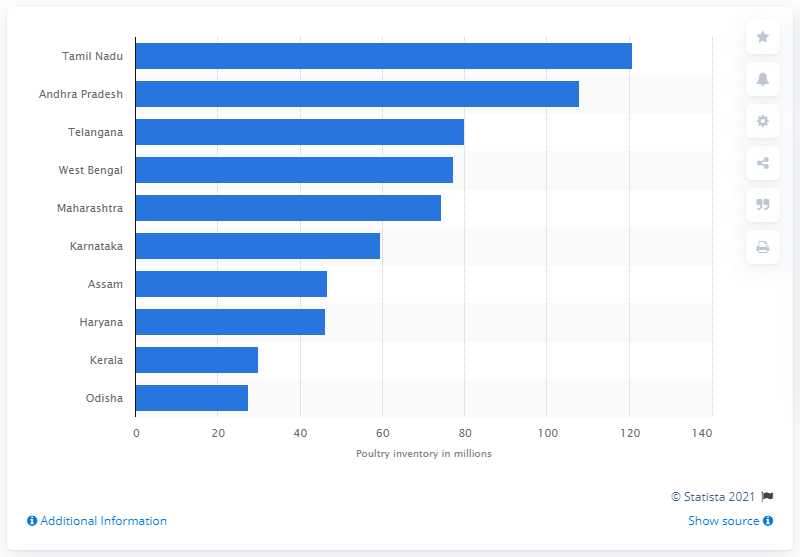Point out several critical features in this image. According to the latest data from 2019, the state of Telangana had the largest poultry population in India. According to the data available in 2019, the state of Andhra Pradesh had the largest poultry population in India. Tamil Nadu's poultry population in 2019 was estimated to be 120.8 million birds. 